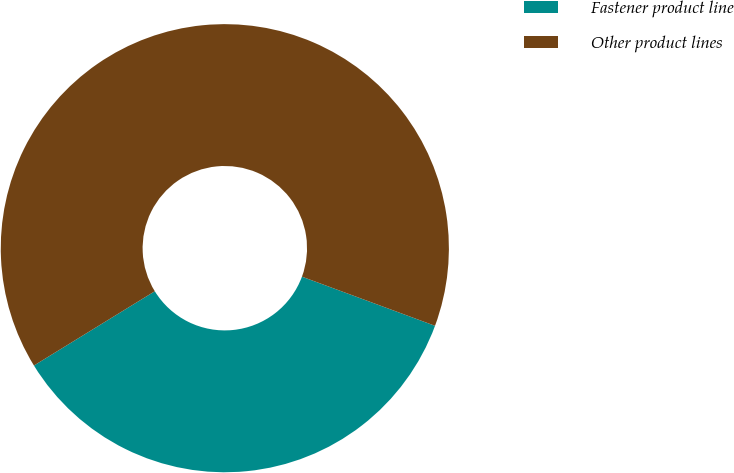Convert chart. <chart><loc_0><loc_0><loc_500><loc_500><pie_chart><fcel>Fastener product line<fcel>Other product lines<nl><fcel>35.6%<fcel>64.4%<nl></chart> 